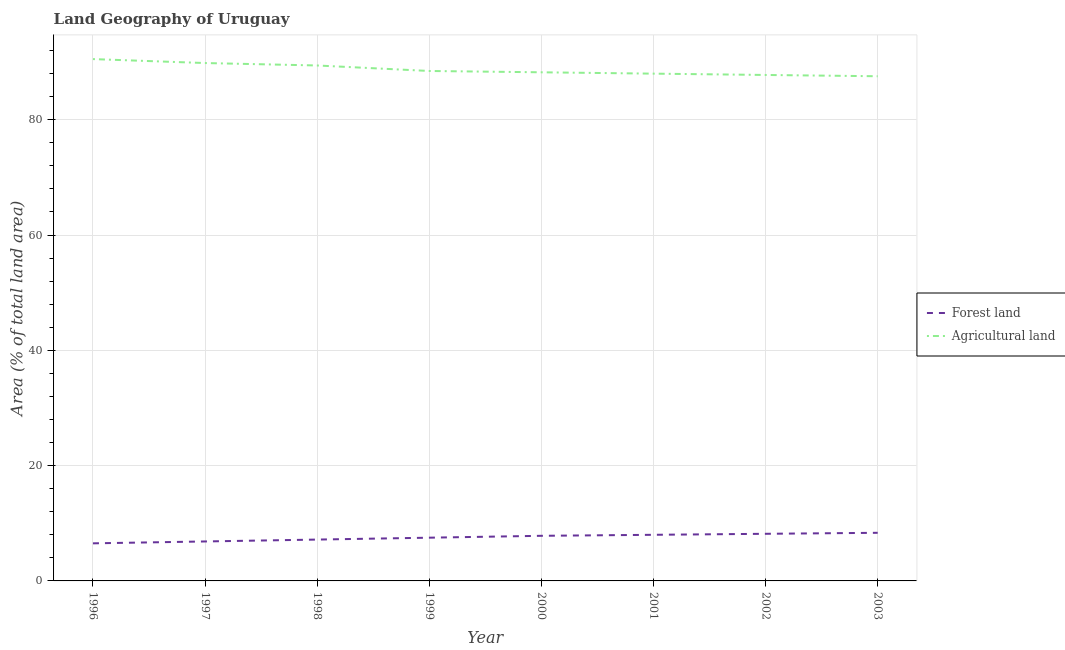How many different coloured lines are there?
Your answer should be compact. 2. Does the line corresponding to percentage of land area under agriculture intersect with the line corresponding to percentage of land area under forests?
Give a very brief answer. No. Is the number of lines equal to the number of legend labels?
Provide a short and direct response. Yes. What is the percentage of land area under forests in 2000?
Provide a succinct answer. 7.83. Across all years, what is the maximum percentage of land area under forests?
Make the answer very short. 8.35. Across all years, what is the minimum percentage of land area under forests?
Your response must be concise. 6.52. What is the total percentage of land area under agriculture in the graph?
Your answer should be very brief. 709.72. What is the difference between the percentage of land area under agriculture in 1997 and that in 1999?
Your answer should be very brief. 1.38. What is the difference between the percentage of land area under agriculture in 1996 and the percentage of land area under forests in 1997?
Offer a terse response. 83.67. What is the average percentage of land area under forests per year?
Your answer should be compact. 7.55. In the year 1997, what is the difference between the percentage of land area under agriculture and percentage of land area under forests?
Provide a short and direct response. 82.98. What is the ratio of the percentage of land area under agriculture in 1998 to that in 2003?
Offer a terse response. 1.02. Is the difference between the percentage of land area under forests in 1998 and 2003 greater than the difference between the percentage of land area under agriculture in 1998 and 2003?
Give a very brief answer. No. What is the difference between the highest and the second highest percentage of land area under forests?
Give a very brief answer. 0.17. What is the difference between the highest and the lowest percentage of land area under agriculture?
Your answer should be compact. 2.98. Is the percentage of land area under agriculture strictly less than the percentage of land area under forests over the years?
Keep it short and to the point. No. How many lines are there?
Give a very brief answer. 2. How many years are there in the graph?
Your answer should be very brief. 8. What is the difference between two consecutive major ticks on the Y-axis?
Provide a succinct answer. 20. Does the graph contain grids?
Make the answer very short. Yes. How many legend labels are there?
Ensure brevity in your answer.  2. What is the title of the graph?
Provide a short and direct response. Land Geography of Uruguay. Does "Domestic liabilities" appear as one of the legend labels in the graph?
Provide a succinct answer. No. What is the label or title of the X-axis?
Your answer should be very brief. Year. What is the label or title of the Y-axis?
Offer a terse response. Area (% of total land area). What is the Area (% of total land area) of Forest land in 1996?
Your answer should be very brief. 6.52. What is the Area (% of total land area) of Agricultural land in 1996?
Offer a very short reply. 90.52. What is the Area (% of total land area) of Forest land in 1997?
Offer a terse response. 6.85. What is the Area (% of total land area) of Agricultural land in 1997?
Your answer should be compact. 89.83. What is the Area (% of total land area) of Forest land in 1998?
Offer a very short reply. 7.17. What is the Area (% of total land area) of Agricultural land in 1998?
Keep it short and to the point. 89.41. What is the Area (% of total land area) in Forest land in 1999?
Offer a very short reply. 7.5. What is the Area (% of total land area) of Agricultural land in 1999?
Give a very brief answer. 88.45. What is the Area (% of total land area) in Forest land in 2000?
Offer a terse response. 7.83. What is the Area (% of total land area) in Agricultural land in 2000?
Provide a succinct answer. 88.22. What is the Area (% of total land area) of Forest land in 2001?
Offer a terse response. 8. What is the Area (% of total land area) of Agricultural land in 2001?
Ensure brevity in your answer.  87.99. What is the Area (% of total land area) in Forest land in 2002?
Your answer should be very brief. 8.17. What is the Area (% of total land area) of Agricultural land in 2002?
Your answer should be very brief. 87.76. What is the Area (% of total land area) of Forest land in 2003?
Provide a succinct answer. 8.35. What is the Area (% of total land area) of Agricultural land in 2003?
Provide a succinct answer. 87.54. Across all years, what is the maximum Area (% of total land area) of Forest land?
Offer a very short reply. 8.35. Across all years, what is the maximum Area (% of total land area) of Agricultural land?
Your answer should be very brief. 90.52. Across all years, what is the minimum Area (% of total land area) of Forest land?
Provide a short and direct response. 6.52. Across all years, what is the minimum Area (% of total land area) in Agricultural land?
Keep it short and to the point. 87.54. What is the total Area (% of total land area) of Forest land in the graph?
Offer a terse response. 60.38. What is the total Area (% of total land area) of Agricultural land in the graph?
Offer a very short reply. 709.72. What is the difference between the Area (% of total land area) in Forest land in 1996 and that in 1997?
Your response must be concise. -0.33. What is the difference between the Area (% of total land area) of Agricultural land in 1996 and that in 1997?
Offer a terse response. 0.69. What is the difference between the Area (% of total land area) in Forest land in 1996 and that in 1998?
Provide a short and direct response. -0.65. What is the difference between the Area (% of total land area) in Agricultural land in 1996 and that in 1998?
Offer a terse response. 1.11. What is the difference between the Area (% of total land area) in Forest land in 1996 and that in 1999?
Make the answer very short. -0.98. What is the difference between the Area (% of total land area) in Agricultural land in 1996 and that in 1999?
Ensure brevity in your answer.  2.06. What is the difference between the Area (% of total land area) of Forest land in 1996 and that in 2000?
Offer a very short reply. -1.31. What is the difference between the Area (% of total land area) of Agricultural land in 1996 and that in 2000?
Make the answer very short. 2.29. What is the difference between the Area (% of total land area) in Forest land in 1996 and that in 2001?
Offer a very short reply. -1.48. What is the difference between the Area (% of total land area) of Agricultural land in 1996 and that in 2001?
Keep it short and to the point. 2.53. What is the difference between the Area (% of total land area) of Forest land in 1996 and that in 2002?
Give a very brief answer. -1.65. What is the difference between the Area (% of total land area) in Agricultural land in 1996 and that in 2002?
Your answer should be compact. 2.75. What is the difference between the Area (% of total land area) in Forest land in 1996 and that in 2003?
Provide a short and direct response. -1.83. What is the difference between the Area (% of total land area) of Agricultural land in 1996 and that in 2003?
Offer a terse response. 2.98. What is the difference between the Area (% of total land area) in Forest land in 1997 and that in 1998?
Offer a terse response. -0.33. What is the difference between the Area (% of total land area) in Agricultural land in 1997 and that in 1998?
Your response must be concise. 0.42. What is the difference between the Area (% of total land area) of Forest land in 1997 and that in 1999?
Offer a very short reply. -0.65. What is the difference between the Area (% of total land area) in Agricultural land in 1997 and that in 1999?
Keep it short and to the point. 1.38. What is the difference between the Area (% of total land area) of Forest land in 1997 and that in 2000?
Ensure brevity in your answer.  -0.98. What is the difference between the Area (% of total land area) in Agricultural land in 1997 and that in 2000?
Give a very brief answer. 1.61. What is the difference between the Area (% of total land area) of Forest land in 1997 and that in 2001?
Your answer should be compact. -1.15. What is the difference between the Area (% of total land area) in Agricultural land in 1997 and that in 2001?
Make the answer very short. 1.84. What is the difference between the Area (% of total land area) in Forest land in 1997 and that in 2002?
Your response must be concise. -1.33. What is the difference between the Area (% of total land area) in Agricultural land in 1997 and that in 2002?
Your answer should be compact. 2.07. What is the difference between the Area (% of total land area) of Forest land in 1997 and that in 2003?
Make the answer very short. -1.5. What is the difference between the Area (% of total land area) of Agricultural land in 1997 and that in 2003?
Offer a very short reply. 2.29. What is the difference between the Area (% of total land area) of Forest land in 1998 and that in 1999?
Your answer should be very brief. -0.33. What is the difference between the Area (% of total land area) in Agricultural land in 1998 and that in 1999?
Your answer should be very brief. 0.95. What is the difference between the Area (% of total land area) in Forest land in 1998 and that in 2000?
Your answer should be compact. -0.65. What is the difference between the Area (% of total land area) in Agricultural land in 1998 and that in 2000?
Offer a very short reply. 1.18. What is the difference between the Area (% of total land area) in Forest land in 1998 and that in 2001?
Give a very brief answer. -0.83. What is the difference between the Area (% of total land area) in Agricultural land in 1998 and that in 2001?
Provide a short and direct response. 1.42. What is the difference between the Area (% of total land area) in Forest land in 1998 and that in 2002?
Give a very brief answer. -1. What is the difference between the Area (% of total land area) of Agricultural land in 1998 and that in 2002?
Give a very brief answer. 1.65. What is the difference between the Area (% of total land area) of Forest land in 1998 and that in 2003?
Your response must be concise. -1.18. What is the difference between the Area (% of total land area) of Agricultural land in 1998 and that in 2003?
Your answer should be very brief. 1.87. What is the difference between the Area (% of total land area) of Forest land in 1999 and that in 2000?
Provide a succinct answer. -0.33. What is the difference between the Area (% of total land area) in Agricultural land in 1999 and that in 2000?
Provide a short and direct response. 0.23. What is the difference between the Area (% of total land area) in Forest land in 1999 and that in 2001?
Keep it short and to the point. -0.5. What is the difference between the Area (% of total land area) in Agricultural land in 1999 and that in 2001?
Your response must be concise. 0.46. What is the difference between the Area (% of total land area) in Forest land in 1999 and that in 2002?
Your answer should be compact. -0.67. What is the difference between the Area (% of total land area) in Agricultural land in 1999 and that in 2002?
Your response must be concise. 0.69. What is the difference between the Area (% of total land area) in Forest land in 1999 and that in 2003?
Your answer should be compact. -0.85. What is the difference between the Area (% of total land area) in Agricultural land in 1999 and that in 2003?
Ensure brevity in your answer.  0.91. What is the difference between the Area (% of total land area) in Forest land in 2000 and that in 2001?
Offer a terse response. -0.17. What is the difference between the Area (% of total land area) in Agricultural land in 2000 and that in 2001?
Offer a terse response. 0.23. What is the difference between the Area (% of total land area) of Forest land in 2000 and that in 2002?
Keep it short and to the point. -0.35. What is the difference between the Area (% of total land area) in Agricultural land in 2000 and that in 2002?
Offer a terse response. 0.46. What is the difference between the Area (% of total land area) in Forest land in 2000 and that in 2003?
Your answer should be compact. -0.52. What is the difference between the Area (% of total land area) of Agricultural land in 2000 and that in 2003?
Offer a terse response. 0.69. What is the difference between the Area (% of total land area) of Forest land in 2001 and that in 2002?
Ensure brevity in your answer.  -0.17. What is the difference between the Area (% of total land area) in Agricultural land in 2001 and that in 2002?
Your answer should be compact. 0.23. What is the difference between the Area (% of total land area) in Forest land in 2001 and that in 2003?
Provide a short and direct response. -0.35. What is the difference between the Area (% of total land area) of Agricultural land in 2001 and that in 2003?
Give a very brief answer. 0.45. What is the difference between the Area (% of total land area) in Forest land in 2002 and that in 2003?
Your answer should be compact. -0.17. What is the difference between the Area (% of total land area) of Agricultural land in 2002 and that in 2003?
Offer a terse response. 0.22. What is the difference between the Area (% of total land area) of Forest land in 1996 and the Area (% of total land area) of Agricultural land in 1997?
Provide a short and direct response. -83.31. What is the difference between the Area (% of total land area) in Forest land in 1996 and the Area (% of total land area) in Agricultural land in 1998?
Provide a short and direct response. -82.89. What is the difference between the Area (% of total land area) in Forest land in 1996 and the Area (% of total land area) in Agricultural land in 1999?
Give a very brief answer. -81.93. What is the difference between the Area (% of total land area) in Forest land in 1996 and the Area (% of total land area) in Agricultural land in 2000?
Make the answer very short. -81.71. What is the difference between the Area (% of total land area) of Forest land in 1996 and the Area (% of total land area) of Agricultural land in 2001?
Make the answer very short. -81.47. What is the difference between the Area (% of total land area) of Forest land in 1996 and the Area (% of total land area) of Agricultural land in 2002?
Keep it short and to the point. -81.24. What is the difference between the Area (% of total land area) of Forest land in 1996 and the Area (% of total land area) of Agricultural land in 2003?
Offer a terse response. -81.02. What is the difference between the Area (% of total land area) in Forest land in 1997 and the Area (% of total land area) in Agricultural land in 1998?
Your answer should be compact. -82.56. What is the difference between the Area (% of total land area) of Forest land in 1997 and the Area (% of total land area) of Agricultural land in 1999?
Provide a short and direct response. -81.61. What is the difference between the Area (% of total land area) in Forest land in 1997 and the Area (% of total land area) in Agricultural land in 2000?
Offer a terse response. -81.38. What is the difference between the Area (% of total land area) of Forest land in 1997 and the Area (% of total land area) of Agricultural land in 2001?
Ensure brevity in your answer.  -81.14. What is the difference between the Area (% of total land area) of Forest land in 1997 and the Area (% of total land area) of Agricultural land in 2002?
Provide a succinct answer. -80.92. What is the difference between the Area (% of total land area) of Forest land in 1997 and the Area (% of total land area) of Agricultural land in 2003?
Ensure brevity in your answer.  -80.69. What is the difference between the Area (% of total land area) of Forest land in 1998 and the Area (% of total land area) of Agricultural land in 1999?
Offer a terse response. -81.28. What is the difference between the Area (% of total land area) in Forest land in 1998 and the Area (% of total land area) in Agricultural land in 2000?
Give a very brief answer. -81.05. What is the difference between the Area (% of total land area) in Forest land in 1998 and the Area (% of total land area) in Agricultural land in 2001?
Give a very brief answer. -80.82. What is the difference between the Area (% of total land area) in Forest land in 1998 and the Area (% of total land area) in Agricultural land in 2002?
Offer a very short reply. -80.59. What is the difference between the Area (% of total land area) in Forest land in 1998 and the Area (% of total land area) in Agricultural land in 2003?
Provide a succinct answer. -80.37. What is the difference between the Area (% of total land area) of Forest land in 1999 and the Area (% of total land area) of Agricultural land in 2000?
Give a very brief answer. -80.72. What is the difference between the Area (% of total land area) of Forest land in 1999 and the Area (% of total land area) of Agricultural land in 2001?
Provide a short and direct response. -80.49. What is the difference between the Area (% of total land area) in Forest land in 1999 and the Area (% of total land area) in Agricultural land in 2002?
Ensure brevity in your answer.  -80.26. What is the difference between the Area (% of total land area) of Forest land in 1999 and the Area (% of total land area) of Agricultural land in 2003?
Your response must be concise. -80.04. What is the difference between the Area (% of total land area) in Forest land in 2000 and the Area (% of total land area) in Agricultural land in 2001?
Your response must be concise. -80.16. What is the difference between the Area (% of total land area) of Forest land in 2000 and the Area (% of total land area) of Agricultural land in 2002?
Give a very brief answer. -79.94. What is the difference between the Area (% of total land area) in Forest land in 2000 and the Area (% of total land area) in Agricultural land in 2003?
Keep it short and to the point. -79.71. What is the difference between the Area (% of total land area) in Forest land in 2001 and the Area (% of total land area) in Agricultural land in 2002?
Your answer should be compact. -79.76. What is the difference between the Area (% of total land area) in Forest land in 2001 and the Area (% of total land area) in Agricultural land in 2003?
Your answer should be very brief. -79.54. What is the difference between the Area (% of total land area) of Forest land in 2002 and the Area (% of total land area) of Agricultural land in 2003?
Offer a very short reply. -79.36. What is the average Area (% of total land area) of Forest land per year?
Make the answer very short. 7.55. What is the average Area (% of total land area) of Agricultural land per year?
Offer a terse response. 88.71. In the year 1996, what is the difference between the Area (% of total land area) of Forest land and Area (% of total land area) of Agricultural land?
Offer a very short reply. -84. In the year 1997, what is the difference between the Area (% of total land area) of Forest land and Area (% of total land area) of Agricultural land?
Provide a succinct answer. -82.98. In the year 1998, what is the difference between the Area (% of total land area) in Forest land and Area (% of total land area) in Agricultural land?
Ensure brevity in your answer.  -82.23. In the year 1999, what is the difference between the Area (% of total land area) in Forest land and Area (% of total land area) in Agricultural land?
Keep it short and to the point. -80.95. In the year 2000, what is the difference between the Area (% of total land area) of Forest land and Area (% of total land area) of Agricultural land?
Provide a succinct answer. -80.4. In the year 2001, what is the difference between the Area (% of total land area) in Forest land and Area (% of total land area) in Agricultural land?
Your answer should be compact. -79.99. In the year 2002, what is the difference between the Area (% of total land area) of Forest land and Area (% of total land area) of Agricultural land?
Ensure brevity in your answer.  -79.59. In the year 2003, what is the difference between the Area (% of total land area) in Forest land and Area (% of total land area) in Agricultural land?
Offer a very short reply. -79.19. What is the ratio of the Area (% of total land area) in Forest land in 1996 to that in 1997?
Your answer should be very brief. 0.95. What is the ratio of the Area (% of total land area) in Agricultural land in 1996 to that in 1997?
Offer a very short reply. 1.01. What is the ratio of the Area (% of total land area) of Forest land in 1996 to that in 1998?
Ensure brevity in your answer.  0.91. What is the ratio of the Area (% of total land area) of Agricultural land in 1996 to that in 1998?
Provide a short and direct response. 1.01. What is the ratio of the Area (% of total land area) in Forest land in 1996 to that in 1999?
Your answer should be very brief. 0.87. What is the ratio of the Area (% of total land area) of Agricultural land in 1996 to that in 1999?
Provide a short and direct response. 1.02. What is the ratio of the Area (% of total land area) in Forest land in 1996 to that in 2000?
Offer a very short reply. 0.83. What is the ratio of the Area (% of total land area) in Forest land in 1996 to that in 2001?
Offer a terse response. 0.81. What is the ratio of the Area (% of total land area) in Agricultural land in 1996 to that in 2001?
Ensure brevity in your answer.  1.03. What is the ratio of the Area (% of total land area) of Forest land in 1996 to that in 2002?
Offer a terse response. 0.8. What is the ratio of the Area (% of total land area) in Agricultural land in 1996 to that in 2002?
Make the answer very short. 1.03. What is the ratio of the Area (% of total land area) of Forest land in 1996 to that in 2003?
Ensure brevity in your answer.  0.78. What is the ratio of the Area (% of total land area) of Agricultural land in 1996 to that in 2003?
Your answer should be very brief. 1.03. What is the ratio of the Area (% of total land area) of Forest land in 1997 to that in 1998?
Offer a terse response. 0.95. What is the ratio of the Area (% of total land area) in Agricultural land in 1997 to that in 1998?
Your answer should be very brief. 1. What is the ratio of the Area (% of total land area) of Forest land in 1997 to that in 1999?
Your response must be concise. 0.91. What is the ratio of the Area (% of total land area) in Agricultural land in 1997 to that in 1999?
Give a very brief answer. 1.02. What is the ratio of the Area (% of total land area) in Forest land in 1997 to that in 2000?
Your answer should be very brief. 0.87. What is the ratio of the Area (% of total land area) of Agricultural land in 1997 to that in 2000?
Ensure brevity in your answer.  1.02. What is the ratio of the Area (% of total land area) in Forest land in 1997 to that in 2001?
Your answer should be compact. 0.86. What is the ratio of the Area (% of total land area) of Agricultural land in 1997 to that in 2001?
Your answer should be compact. 1.02. What is the ratio of the Area (% of total land area) in Forest land in 1997 to that in 2002?
Offer a terse response. 0.84. What is the ratio of the Area (% of total land area) in Agricultural land in 1997 to that in 2002?
Offer a very short reply. 1.02. What is the ratio of the Area (% of total land area) in Forest land in 1997 to that in 2003?
Provide a short and direct response. 0.82. What is the ratio of the Area (% of total land area) of Agricultural land in 1997 to that in 2003?
Ensure brevity in your answer.  1.03. What is the ratio of the Area (% of total land area) in Forest land in 1998 to that in 1999?
Provide a short and direct response. 0.96. What is the ratio of the Area (% of total land area) of Agricultural land in 1998 to that in 1999?
Make the answer very short. 1.01. What is the ratio of the Area (% of total land area) of Forest land in 1998 to that in 2000?
Offer a terse response. 0.92. What is the ratio of the Area (% of total land area) of Agricultural land in 1998 to that in 2000?
Your answer should be compact. 1.01. What is the ratio of the Area (% of total land area) in Forest land in 1998 to that in 2001?
Provide a short and direct response. 0.9. What is the ratio of the Area (% of total land area) in Agricultural land in 1998 to that in 2001?
Make the answer very short. 1.02. What is the ratio of the Area (% of total land area) in Forest land in 1998 to that in 2002?
Your answer should be compact. 0.88. What is the ratio of the Area (% of total land area) in Agricultural land in 1998 to that in 2002?
Make the answer very short. 1.02. What is the ratio of the Area (% of total land area) of Forest land in 1998 to that in 2003?
Offer a very short reply. 0.86. What is the ratio of the Area (% of total land area) of Agricultural land in 1998 to that in 2003?
Your answer should be very brief. 1.02. What is the ratio of the Area (% of total land area) of Forest land in 1999 to that in 2000?
Make the answer very short. 0.96. What is the ratio of the Area (% of total land area) in Forest land in 1999 to that in 2001?
Make the answer very short. 0.94. What is the ratio of the Area (% of total land area) in Forest land in 1999 to that in 2002?
Your answer should be very brief. 0.92. What is the ratio of the Area (% of total land area) in Agricultural land in 1999 to that in 2002?
Give a very brief answer. 1.01. What is the ratio of the Area (% of total land area) of Forest land in 1999 to that in 2003?
Offer a terse response. 0.9. What is the ratio of the Area (% of total land area) of Agricultural land in 1999 to that in 2003?
Your answer should be very brief. 1.01. What is the ratio of the Area (% of total land area) in Forest land in 2000 to that in 2001?
Make the answer very short. 0.98. What is the ratio of the Area (% of total land area) in Agricultural land in 2000 to that in 2001?
Offer a very short reply. 1. What is the ratio of the Area (% of total land area) of Forest land in 2000 to that in 2002?
Provide a short and direct response. 0.96. What is the ratio of the Area (% of total land area) in Agricultural land in 2000 to that in 2002?
Make the answer very short. 1.01. What is the ratio of the Area (% of total land area) of Agricultural land in 2000 to that in 2003?
Your answer should be compact. 1.01. What is the ratio of the Area (% of total land area) in Forest land in 2001 to that in 2002?
Make the answer very short. 0.98. What is the ratio of the Area (% of total land area) of Forest land in 2001 to that in 2003?
Ensure brevity in your answer.  0.96. What is the ratio of the Area (% of total land area) of Forest land in 2002 to that in 2003?
Your response must be concise. 0.98. What is the difference between the highest and the second highest Area (% of total land area) in Forest land?
Offer a very short reply. 0.17. What is the difference between the highest and the second highest Area (% of total land area) of Agricultural land?
Make the answer very short. 0.69. What is the difference between the highest and the lowest Area (% of total land area) of Forest land?
Provide a succinct answer. 1.83. What is the difference between the highest and the lowest Area (% of total land area) in Agricultural land?
Your response must be concise. 2.98. 